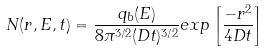<formula> <loc_0><loc_0><loc_500><loc_500>N ( r , E , t ) = \frac { q _ { b } ( E ) } { 8 \pi ^ { 3 / 2 } ( D t ) ^ { 3 / 2 } } e x p \left [ \frac { - r ^ { 2 } } { 4 D t } \right ]</formula> 